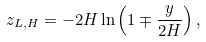<formula> <loc_0><loc_0><loc_500><loc_500>z _ { L , H } = - 2 H \ln \left ( 1 \mp \frac { y } { 2 H } \right ) ,</formula> 